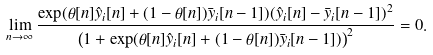<formula> <loc_0><loc_0><loc_500><loc_500>\lim _ { n \to \infty } \frac { \exp ( \theta [ n ] \hat { y } _ { i } [ n ] + ( 1 - \theta [ n ] ) \bar { y } _ { i } [ n - 1 ] ) ( \hat { y } _ { i } [ n ] - \bar { y } _ { i } [ n - 1 ] ) ^ { 2 } } { \left ( 1 + \exp ( \theta [ n ] \hat { y } _ { i } [ n ] + ( 1 - \theta [ n ] ) \bar { y } _ { i } [ n - 1 ] ) \right ) ^ { 2 } } = 0 .</formula> 